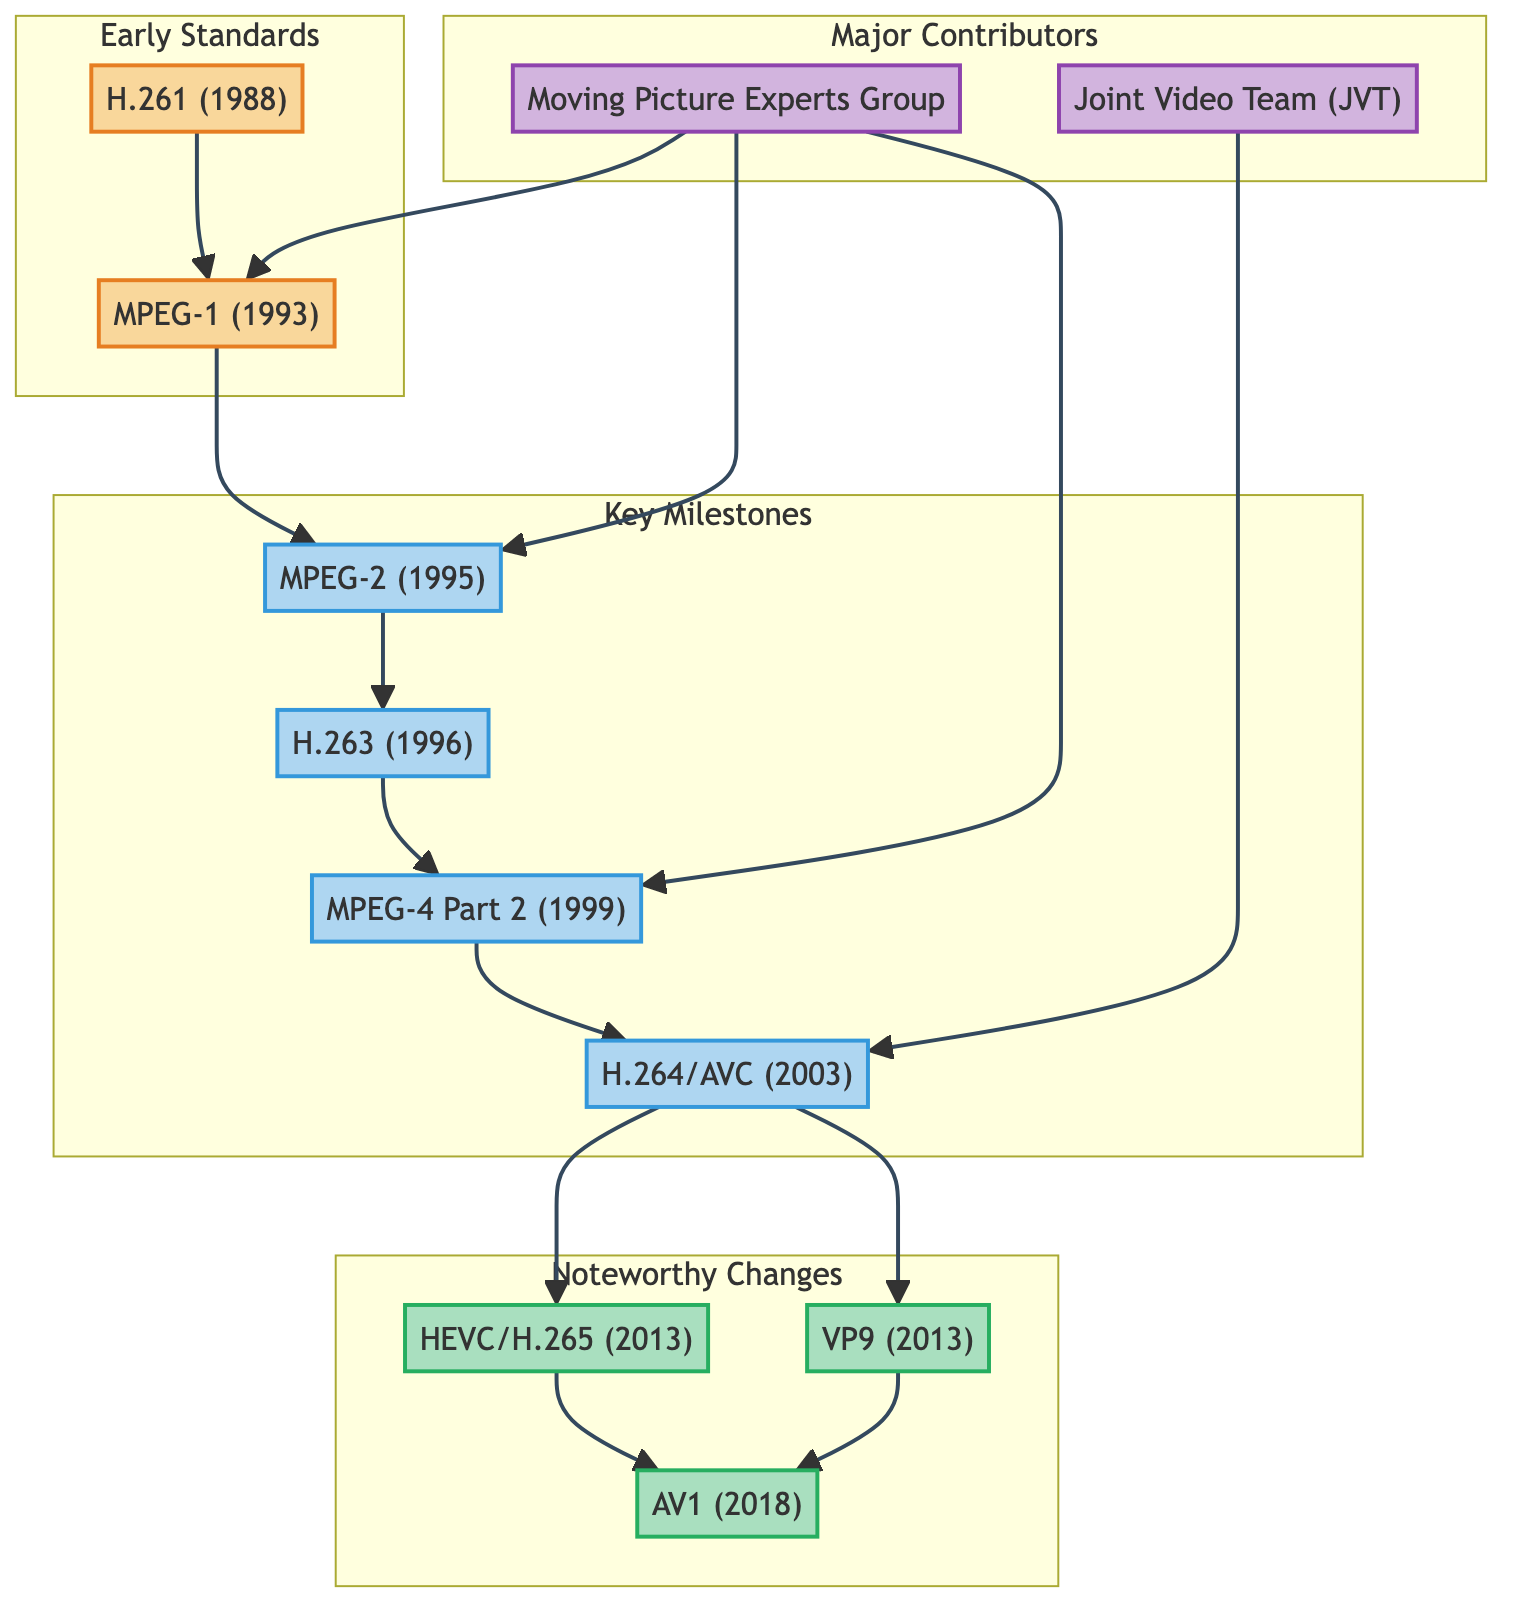What is the first digital video coding standard in the family tree? The diagram shows "H.261 (1988)" as the starting point of the early video standards, indicating that it is the first digital video coding standard.
Answer: H.261 How many key milestones are there in the video encoding workflow history? By counting the nodes under "Key Milestones," there are four distinct milestones represented in the diagram: MPEG-2, H.263, MPEG-4 Part 2, and H.264.
Answer: 4 Who developed H.264/AVC in the diagram? The "Joint Video Team (JVT)" is specifically noted as the contributor responsible for developing H.264/AVC, as indicated in the Major Contributors section of the family tree.
Answer: Joint Video Team (JVT) In what year was HEVC (H.265) introduced? Under the "Noteworthy Changes" section, HEVC (H.265) is marked with the year 2013, making it clear that it was introduced that year.
Answer: 2013 Which technology was succeeded by HEVC? The flow in the diagram traces from H.264 to HEVC, indicating that HEVC succeeded H.264 as a significant development in video encoding technology.
Answer: H.264 How is AV1 different from its predecessors? The family tree indicates that AV1 was developed to offer better compression efficiency than both VP9 and HEVC, highlighting its advancements compared to earlier technologies.
Answer: Better compression efficiency Which organization is responsible for developing MPEG-1? The "Moving Picture Experts Group" is noted as a major contributor in the diagram, specifically linked to the development of MPEG-1, among other standards.
Answer: Moving Picture Experts Group What changed in the evolution of video encoding technology after H.264? The diagram indicates that after H.264, the noteworthy changes include HEVC, VP9, and AV1, which signifies a shift towards better compression techniques and royalty-free options.
Answer: HEVC, VP9, AV1 How many early video standards are listed in the family tree? The "Early Standards" section of the diagram lists two standards: H.261 and MPEG-1, leading to the conclusion that there are two early video standards represented.
Answer: 2 